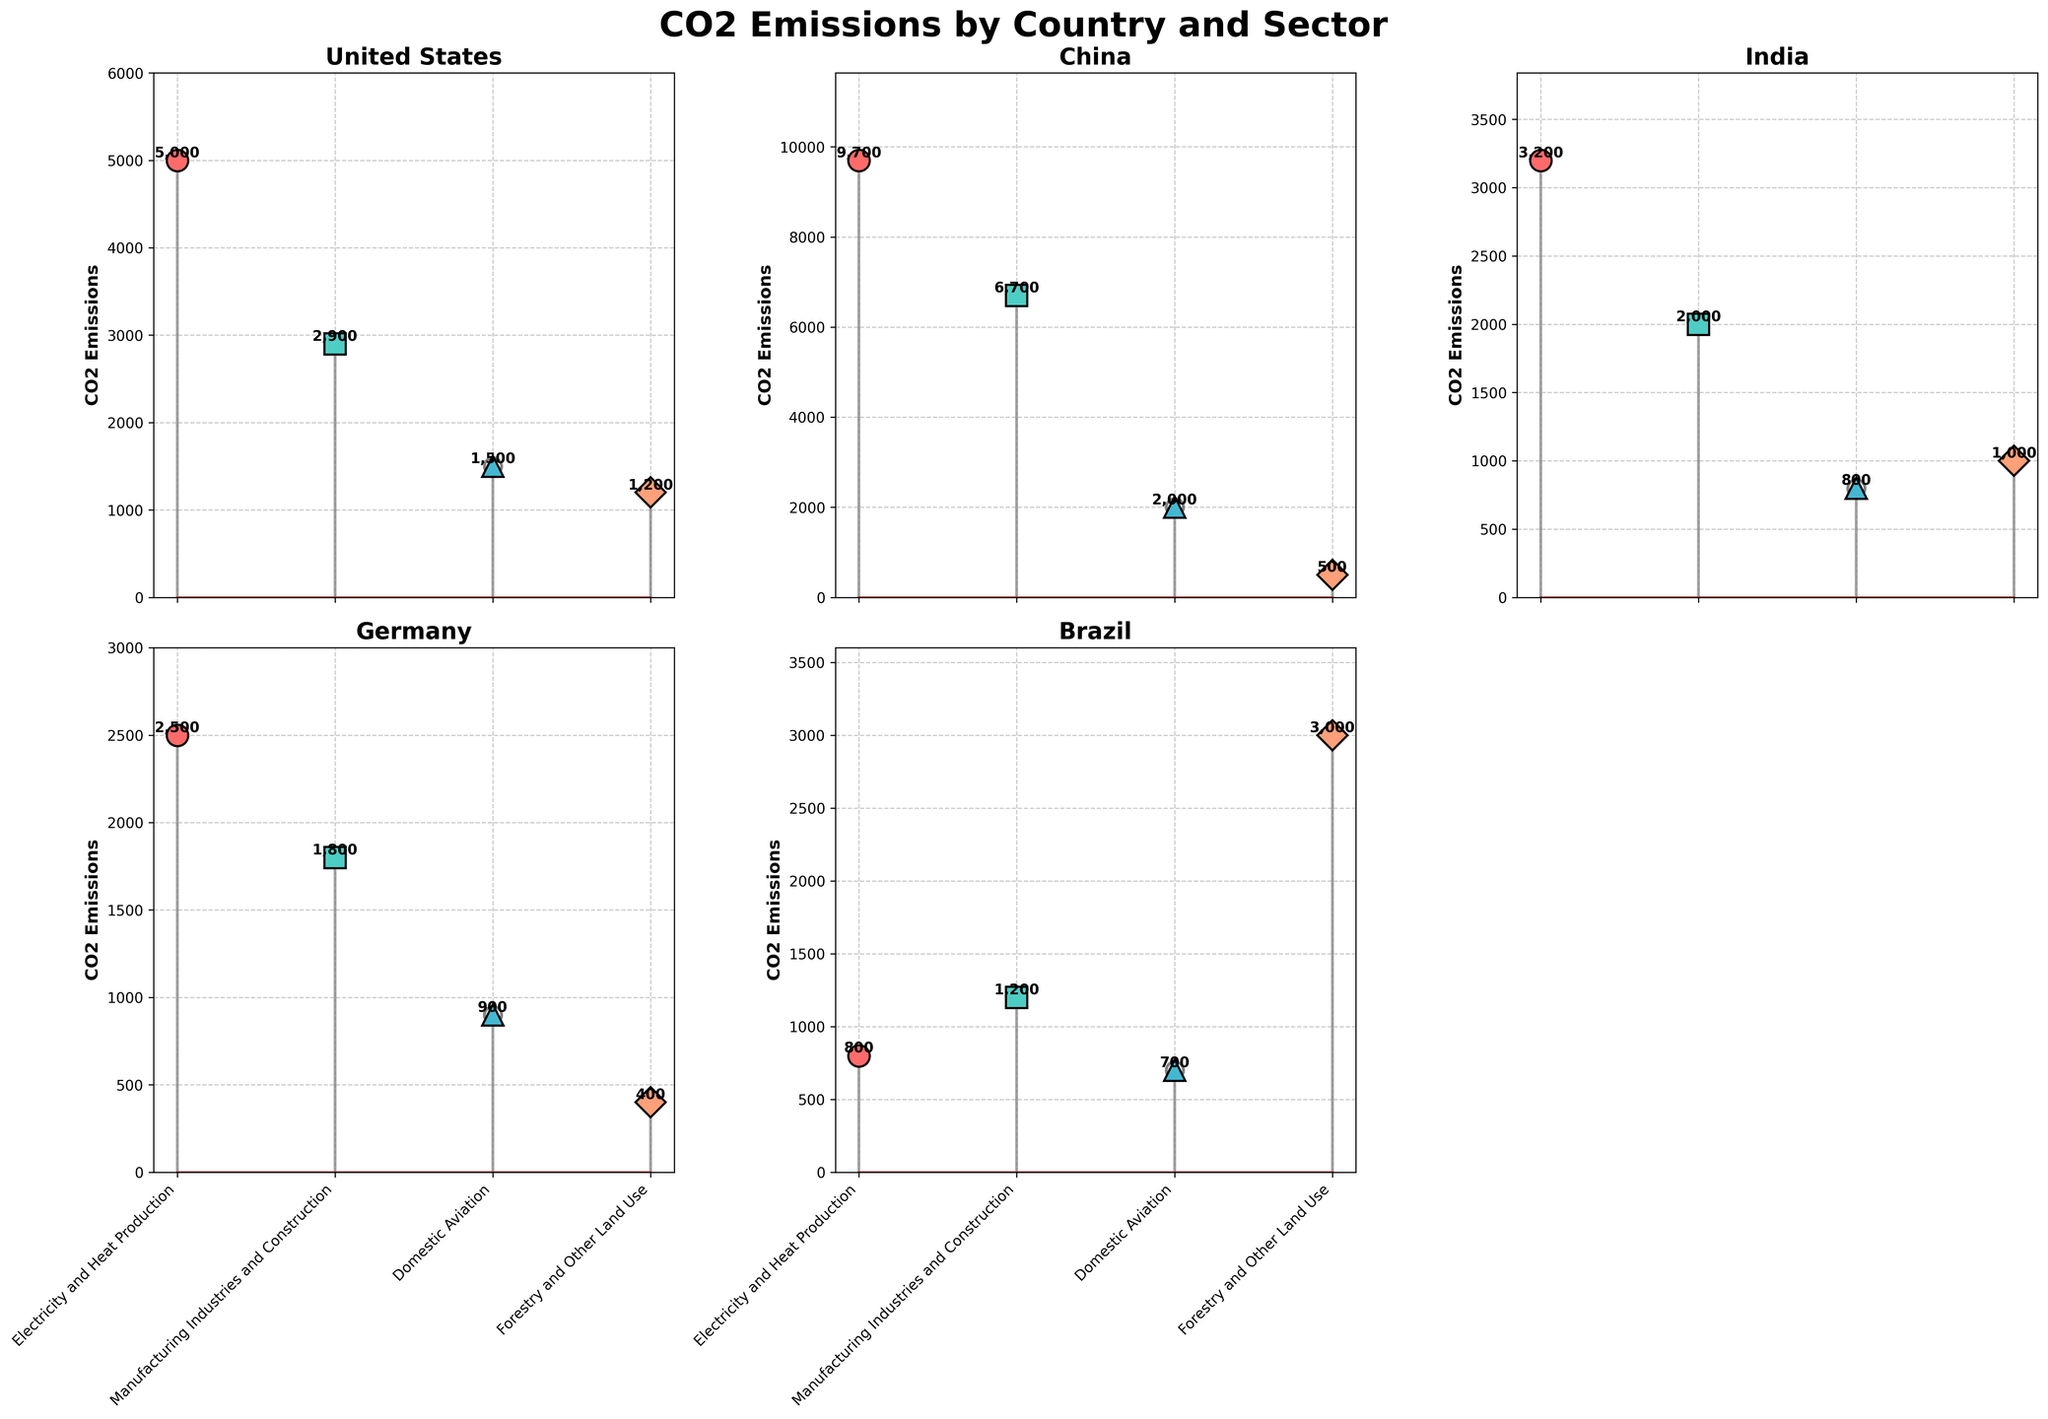What is the title of the figure? The title of the figure is located at the top, in bold and large font. It reads "CO2 Emissions by Country and Sector".
Answer: CO2 Emissions by Country and Sector Which country has the highest CO2 emissions in the "Electricity and Heat Production" sector? By looking at the stem plots for each country, the stem line for China in the "Electricity and Heat Production" sector reaches the highest point compared to other countries.
Answer: China How do the CO2 emissions from "Manufacturing Industries and Construction" in India compare to those in the United States? The stem plot shows the emissions for "Manufacturing Industries and Construction" sector in India and the United States. India's emissions are 2000, while the United States' emissions are 2900. Therefore, India's emissions are lower.
Answer: Lower What is the sum of CO2 emissions for the "Domestic Aviation" sector across all countries? To find the total emissions from "Domestic Aviation", we sum the values shown in the stem plots for each country: 1500 (United States) + 2000 (China) + 800 (India) + 900 (Germany) + 700 (Brazil) = 5900.
Answer: 5900 Which sector contributes the most to CO2 emissions in Brazil? By examining the stem plot for Brazil, we see that the "Agriculture, Forestry and Other Land Use" sector has the highest stem, indicating it has the highest emissions among all sectors in Brazil.
Answer: Agriculture, Forestry and Other Land Use What are the unique shapes or colors used to represent different sectors in the plot? The shapes and colors representing the sectors are circular (red) for "Electricity and Heat Production", square (mint) for "Manufacturing Industries and Construction", triangular (light blue) for "Domestic Aviation", and diamond (peach) for "Agriculture, Forestry and Other Land Use".
Answer: Circular (red), Square (mint), Triangular (light blue), Diamond (peach) Which country has the smallest range of CO2 emissions values across all sectors? To determine the country with the smallest range, we compare the highest and lowest emission values in each country. Brazil has emissions of 3000 (highest from "Agriculture, Forestry and Other Land Use") and 700 (lowest from "Domestic Aviation"), giving a range of 2300, which is the smallest among the countries.
Answer: Brazil What is the average CO2 emissions for the "Electricity and Heat Production" sector across the five countries? To find the average, sum the emissions for "Electricity and Heat Production" across all countries and divide by the number of countries: (5000 + 9700 + 3200 + 2500 + 800) / 5 = 24,200 / 5.
Answer: 4840 Which sector has the most consistent CO2 emissions across all countries? By comparing the stem plots, the sector with the smallest variance in emissions across countries appears to be "Domestic Aviation", as the emissions values are more closely grouped compared to other sectors.
Answer: Domestic Aviation 